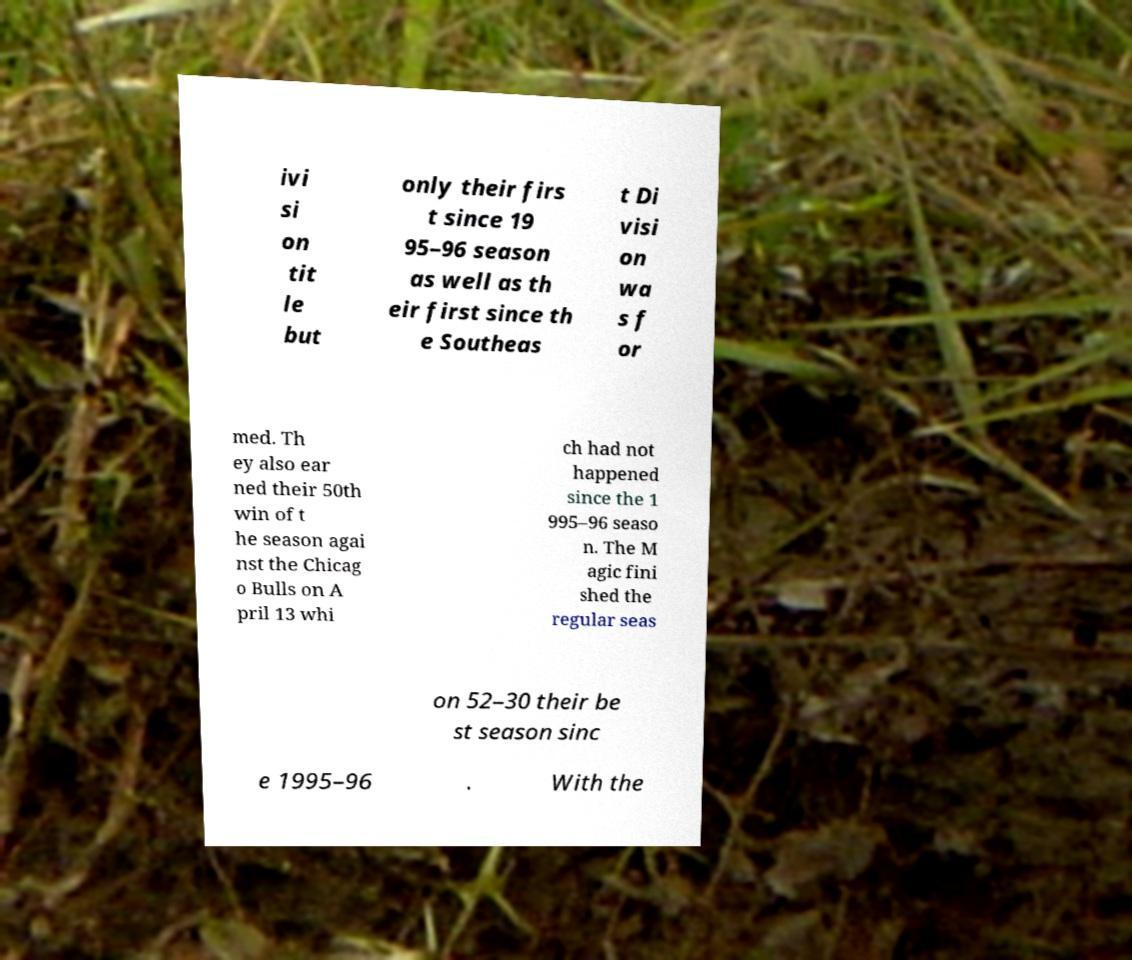What messages or text are displayed in this image? I need them in a readable, typed format. ivi si on tit le but only their firs t since 19 95–96 season as well as th eir first since th e Southeas t Di visi on wa s f or med. Th ey also ear ned their 50th win of t he season agai nst the Chicag o Bulls on A pril 13 whi ch had not happened since the 1 995–96 seaso n. The M agic fini shed the regular seas on 52–30 their be st season sinc e 1995–96 . With the 